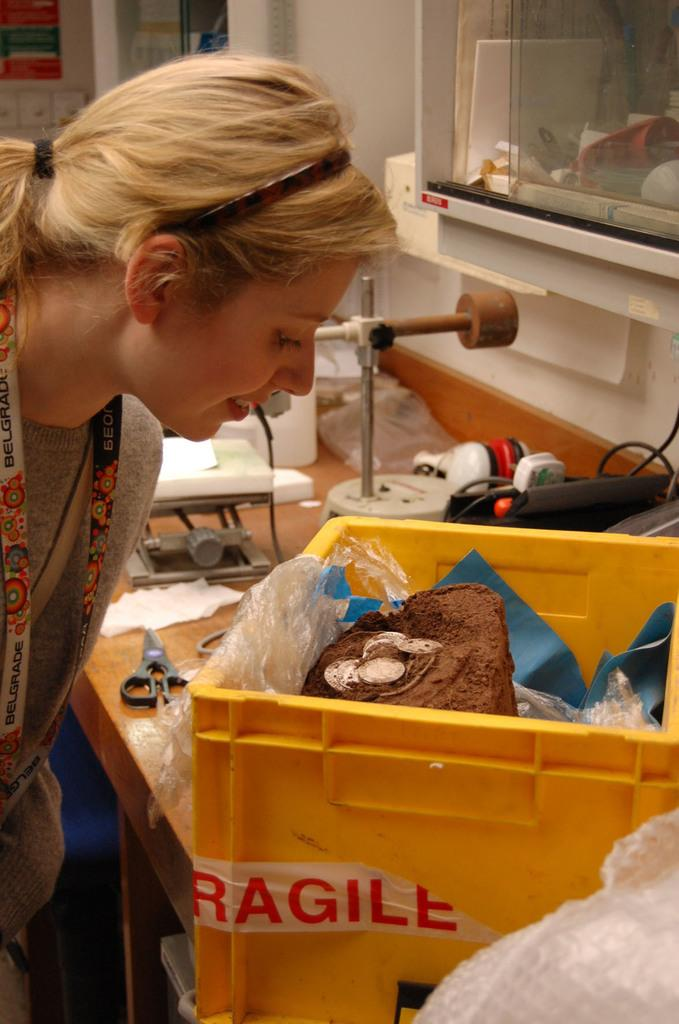Provide a one-sentence caption for the provided image. A woman peers into a yellow container of fragile objects. 